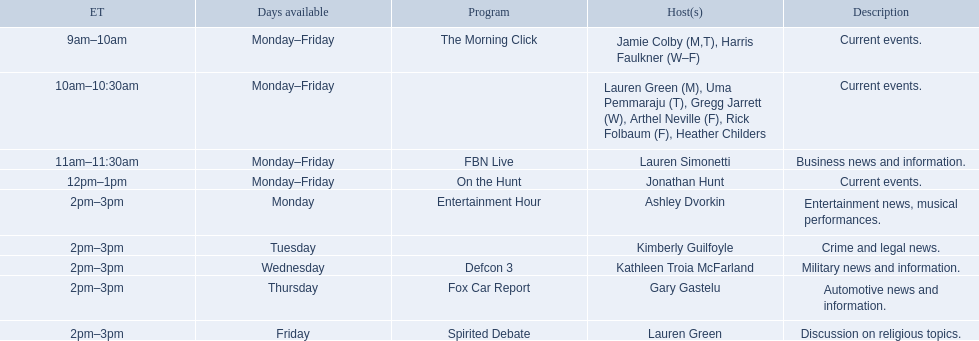What are the names of all the hosts? Jamie Colby (M,T), Harris Faulkner (W–F), Lauren Green (M), Uma Pemmaraju (T), Gregg Jarrett (W), Arthel Neville (F), Rick Folbaum (F), Heather Childers, Lauren Simonetti, Jonathan Hunt, Ashley Dvorkin, Kimberly Guilfoyle, Kathleen Troia McFarland, Gary Gastelu, Lauren Green. What hosts have a show on friday? Jamie Colby (M,T), Harris Faulkner (W–F), Lauren Green (M), Uma Pemmaraju (T), Gregg Jarrett (W), Arthel Neville (F), Rick Folbaum (F), Heather Childers, Lauren Simonetti, Jonathan Hunt, Lauren Green. Can you parse all the data within this table? {'header': ['ET', 'Days available', 'Program', 'Host(s)', 'Description'], 'rows': [['9am–10am', 'Monday–Friday', 'The Morning Click', 'Jamie Colby (M,T), Harris Faulkner (W–F)', 'Current events.'], ['10am–10:30am', 'Monday–Friday', '', 'Lauren Green (M), Uma Pemmaraju (T), Gregg Jarrett (W), Arthel Neville (F), Rick Folbaum (F), Heather Childers', 'Current events.'], ['11am–11:30am', 'Monday–Friday', 'FBN Live', 'Lauren Simonetti', 'Business news and information.'], ['12pm–1pm', 'Monday–Friday', 'On the Hunt', 'Jonathan Hunt', 'Current events.'], ['2pm–3pm', 'Monday', 'Entertainment Hour', 'Ashley Dvorkin', 'Entertainment news, musical performances.'], ['2pm–3pm', 'Tuesday', '', 'Kimberly Guilfoyle', 'Crime and legal news.'], ['2pm–3pm', 'Wednesday', 'Defcon 3', 'Kathleen Troia McFarland', 'Military news and information.'], ['2pm–3pm', 'Thursday', 'Fox Car Report', 'Gary Gastelu', 'Automotive news and information.'], ['2pm–3pm', 'Friday', 'Spirited Debate', 'Lauren Green', 'Discussion on religious topics.']]} Of these hosts, which is the only host with only friday available? Lauren Green. 